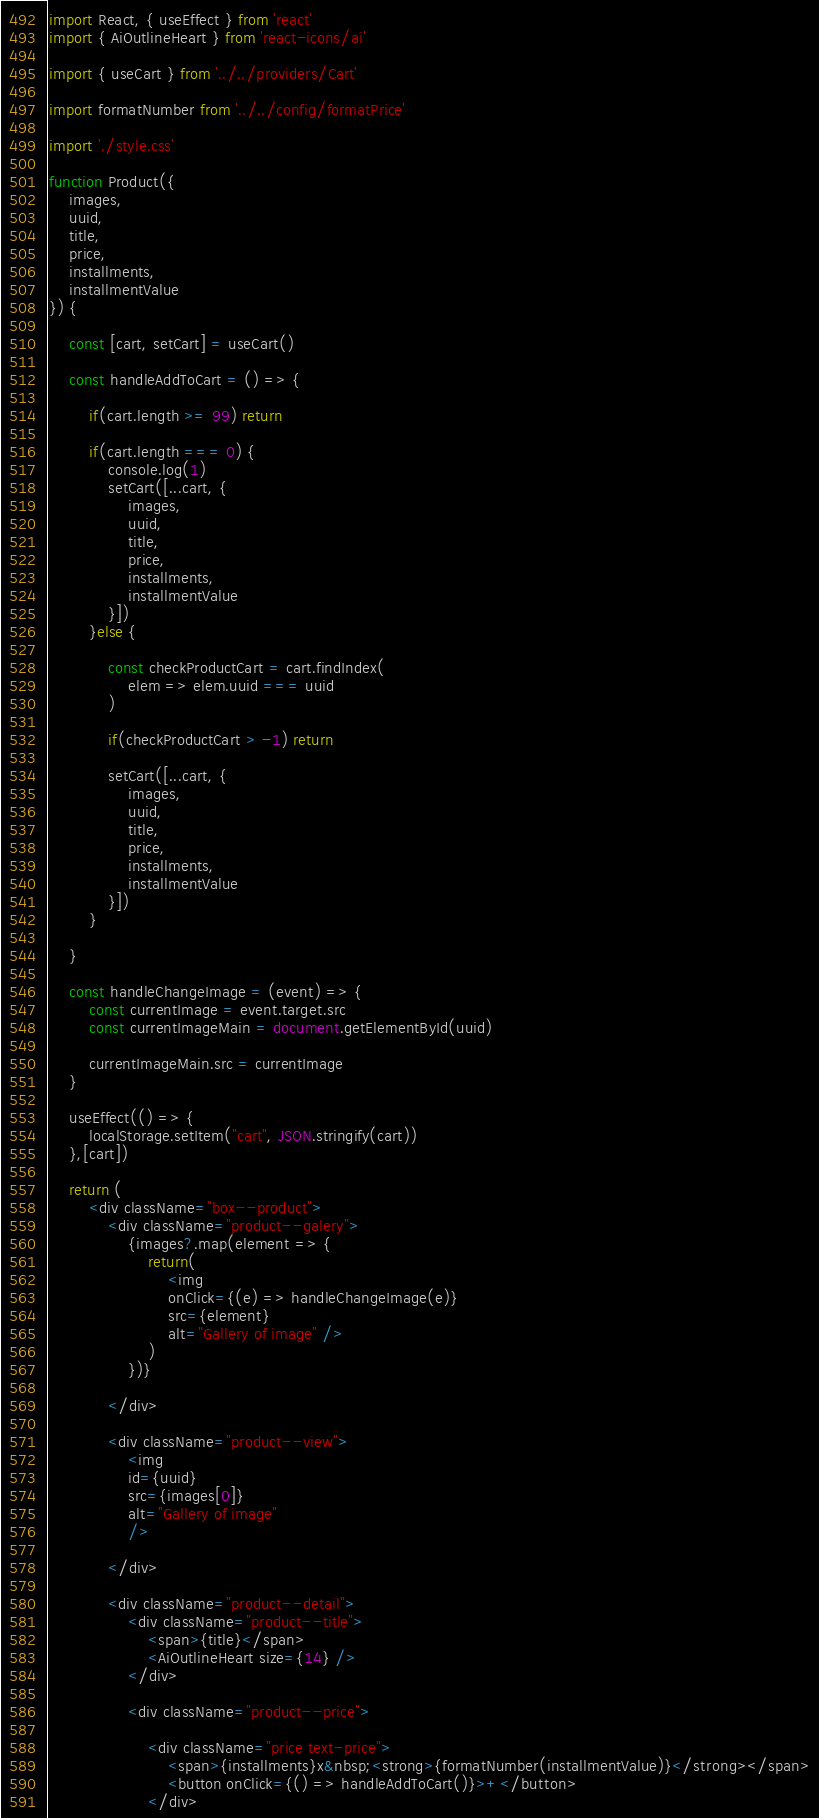Convert code to text. <code><loc_0><loc_0><loc_500><loc_500><_JavaScript_>import React, { useEffect } from 'react'
import { AiOutlineHeart } from 'react-icons/ai'

import { useCart } from '../../providers/Cart'

import formatNumber from '../../config/formatPrice'

import './style.css'

function Product({
	images, 
	uuid,
	title,
	price,
	installments,
	installmentValue
}) {

	const [cart, setCart] = useCart()

	const handleAddToCart = () => {
		
		if(cart.length >= 99) return
		
		if(cart.length === 0) {
			console.log(1)
			setCart([...cart, { 
				images, 
				uuid,
				title,
				price,
				installments,
				installmentValue
			}])
		}else {

			const checkProductCart = cart.findIndex(
				elem => elem.uuid === uuid
			)

			if(checkProductCart > -1) return

			setCart([...cart, { 
				images, 
				uuid,
				title,
				price,
				installments,
				installmentValue
			}])
		}
		
	}

	const handleChangeImage = (event) => {
		const currentImage = event.target.src
		const currentImageMain = document.getElementById(uuid)

		currentImageMain.src = currentImage
	}

	useEffect(() => {
		localStorage.setItem("cart", JSON.stringify(cart))
	},[cart])

	return (
		<div className="box--product">
			<div className="product--galery">
				{images?.map(element => {
					return(
						<img
						onClick={(e) => handleChangeImage(e)} 
						src={element} 
						alt="Gallery of image" />
					)
				})}
				
			</div>

			<div className="product--view">
				<img 
				id={uuid} 
				src={images[0]} 
				alt="Gallery of image"
				/>

			</div>
			
			<div className="product--detail">
				<div className="product--title">
					<span>{title}</span>
					<AiOutlineHeart size={14} />
				</div>

				<div className="product--price">

					<div className="price text-price">
						<span>{installments}x&nbsp;<strong>{formatNumber(installmentValue)}</strong></span>
						<button onClick={() => handleAddToCart()}>+</button>
					</div>
</code> 